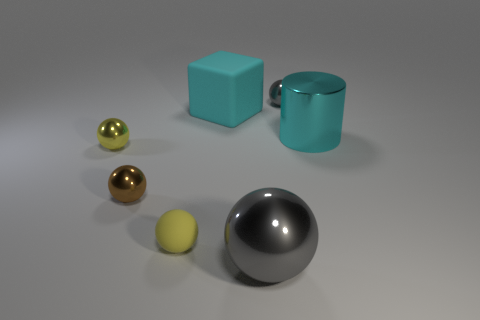What number of things are made of the same material as the tiny gray ball?
Provide a succinct answer. 4. There is a small gray object; is its shape the same as the cyan object in front of the cyan rubber block?
Your answer should be compact. No. Are there any yellow rubber balls that are behind the gray shiny thing left of the gray sphere that is behind the large cyan matte block?
Provide a succinct answer. Yes. There is a gray metallic ball that is behind the small yellow rubber sphere; what size is it?
Provide a succinct answer. Small. What is the material of the gray sphere that is the same size as the brown sphere?
Give a very brief answer. Metal. Does the small brown metallic object have the same shape as the tiny yellow matte thing?
Provide a short and direct response. Yes. How many things are either big cyan cubes or balls that are behind the big cyan shiny object?
Provide a succinct answer. 2. There is a large cylinder that is the same color as the big rubber object; what material is it?
Offer a terse response. Metal. Is the size of the gray shiny thing that is behind the yellow matte object the same as the brown thing?
Offer a terse response. Yes. There is a metallic sphere behind the yellow metallic ball left of the cyan block; how many big cyan matte objects are behind it?
Ensure brevity in your answer.  0. 